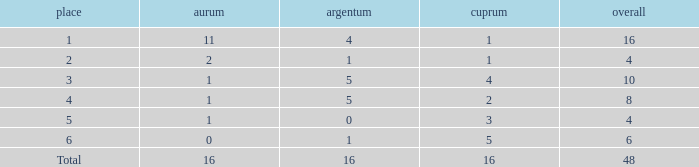How many total gold are less than 4? 0.0. 